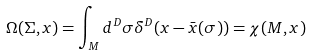Convert formula to latex. <formula><loc_0><loc_0><loc_500><loc_500>\Omega ( \Sigma , x ) = \int _ { M } d ^ { D } \sigma \delta ^ { D } ( x - \bar { x } ( \sigma ) ) = \chi ( M , x )</formula> 